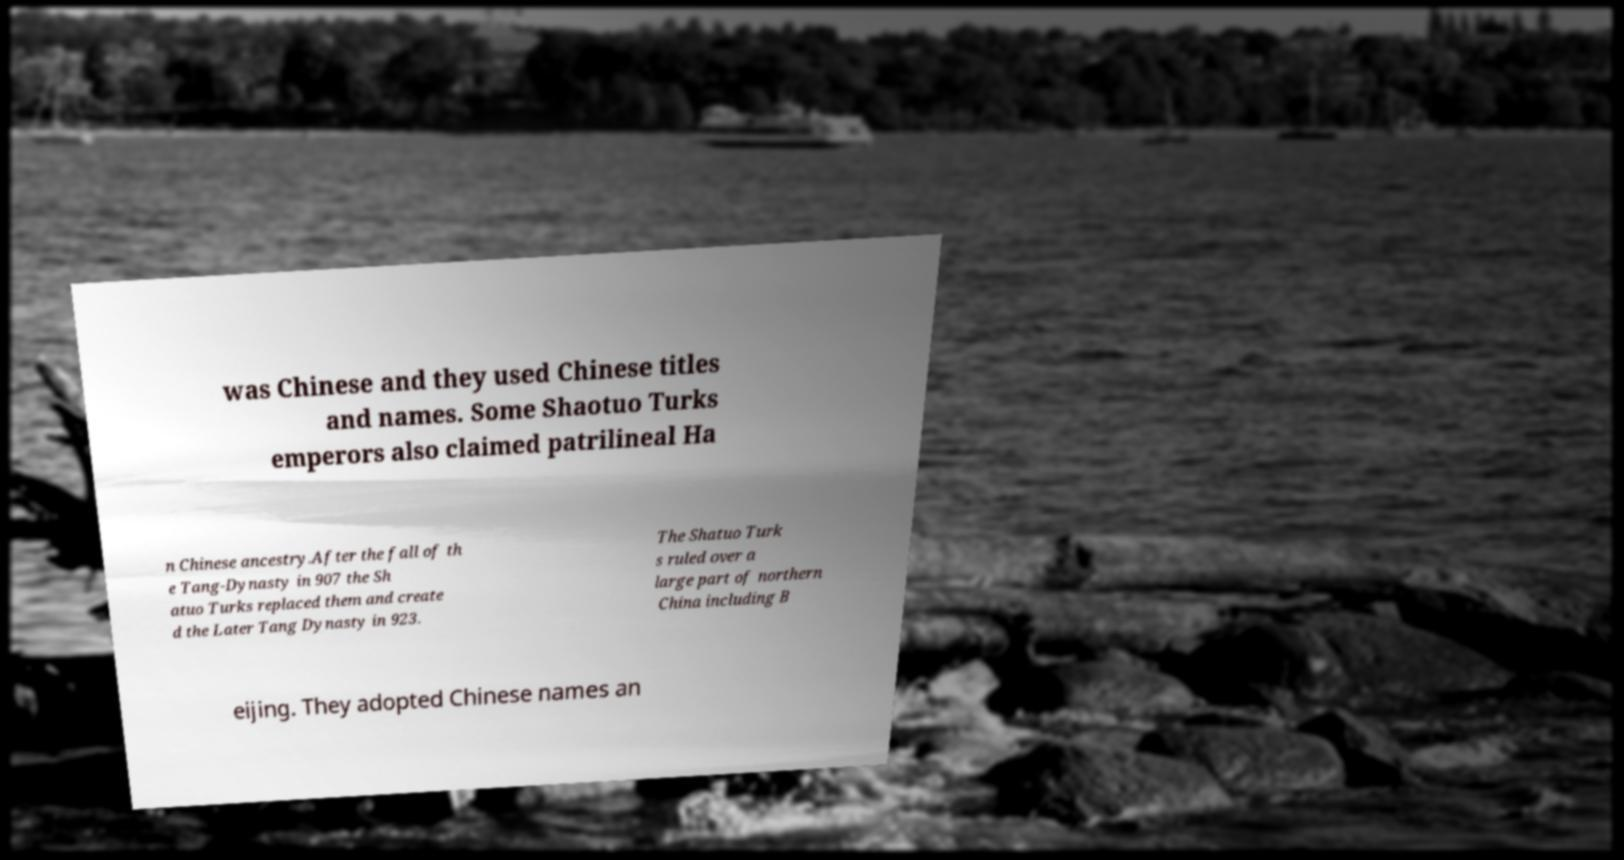Please identify and transcribe the text found in this image. was Chinese and they used Chinese titles and names. Some Shaotuo Turks emperors also claimed patrilineal Ha n Chinese ancestry.After the fall of th e Tang-Dynasty in 907 the Sh atuo Turks replaced them and create d the Later Tang Dynasty in 923. The Shatuo Turk s ruled over a large part of northern China including B eijing. They adopted Chinese names an 